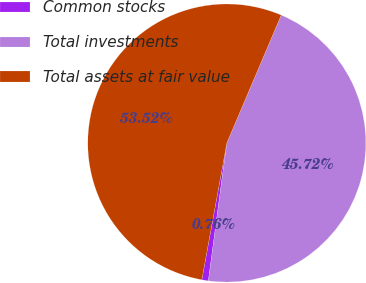Convert chart to OTSL. <chart><loc_0><loc_0><loc_500><loc_500><pie_chart><fcel>Common stocks<fcel>Total investments<fcel>Total assets at fair value<nl><fcel>0.76%<fcel>45.72%<fcel>53.52%<nl></chart> 